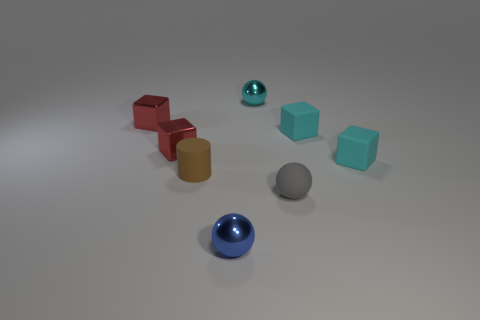Is there any other thing that is the same size as the brown cylinder? Yes, the gray sphere appears to have a similar size to the brown cylinder, providing an interesting look into how different shapes compare when they have comparable dimensions. 